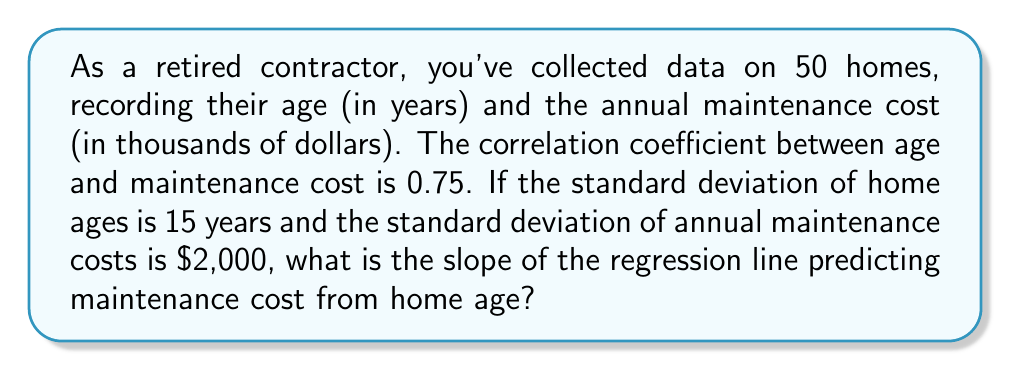Provide a solution to this math problem. To find the slope of the regression line, we'll use the formula:

$$b = r \frac{s_y}{s_x}$$

Where:
$b$ = slope of the regression line
$r$ = correlation coefficient
$s_y$ = standard deviation of the dependent variable (maintenance cost)
$s_x$ = standard deviation of the independent variable (home age)

Given:
$r = 0.75$
$s_x = 15$ years
$s_y = \$2,000 = 2$ thousand dollars

Step 1: Substitute the values into the formula:

$$b = 0.75 \frac{2}{15}$$

Step 2: Simplify the fraction:

$$b = 0.75 \cdot \frac{2}{15} = \frac{0.75 \cdot 2}{15} = \frac{1.5}{15} = 0.1$$

The slope represents the change in y (maintenance cost in thousands of dollars) for a one-unit change in x (age in years).
Answer: $0.1$ thousand dollars per year 